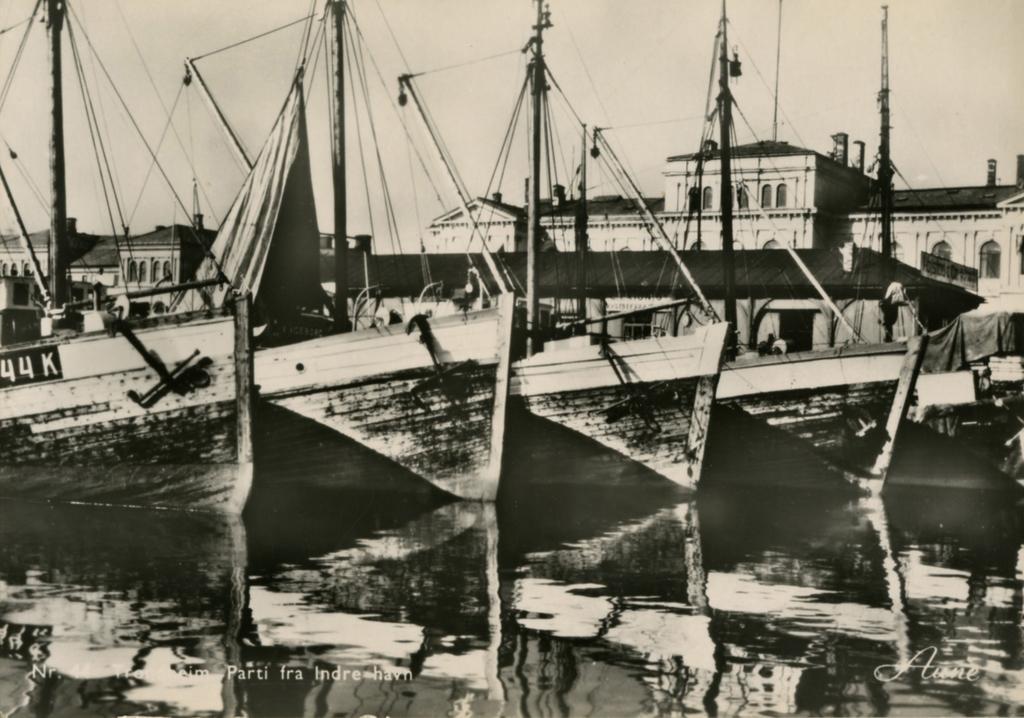How would you summarize this image in a sentence or two? In this image I can see water and in it I can see few boats. On the boat I can see something is written. I can also see few poles, few wires and in the background I can see few buildings. I can also see this image is black and white in colour. 